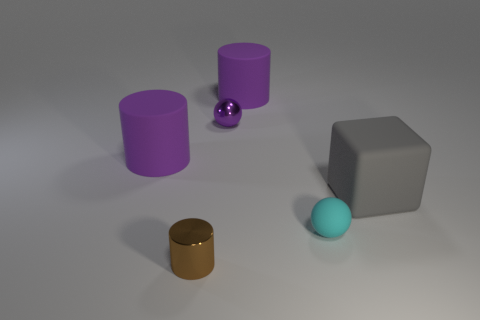Subtract all tiny metallic cylinders. How many cylinders are left? 2 Subtract all blue balls. How many purple cylinders are left? 2 Add 2 big gray rubber objects. How many objects exist? 8 Subtract 1 cylinders. How many cylinders are left? 2 Subtract all cubes. How many objects are left? 5 Add 4 gray metal cylinders. How many gray metal cylinders exist? 4 Subtract 0 red cubes. How many objects are left? 6 Subtract all blue cylinders. Subtract all green spheres. How many cylinders are left? 3 Subtract all small shiny cylinders. Subtract all metallic cylinders. How many objects are left? 4 Add 5 small balls. How many small balls are left? 7 